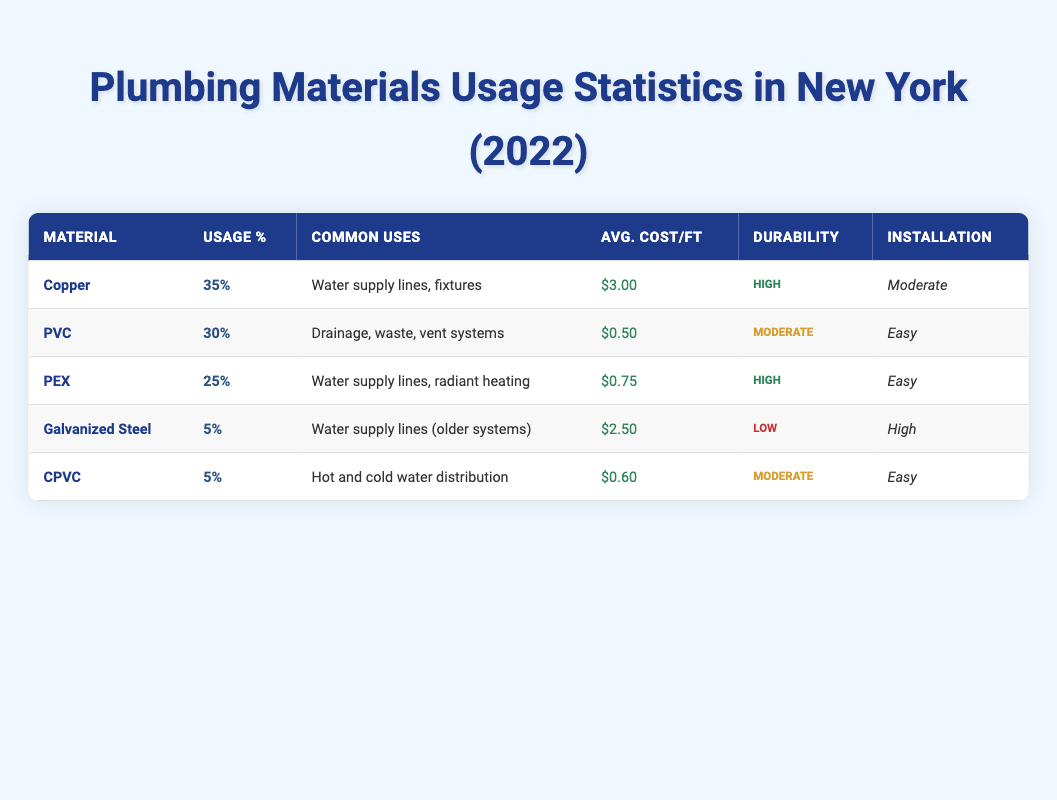What is the usage percentage of Copper among New York plumbers? The table shows that the usage percentage of Copper is listed directly under the "Usage %" column. It states 35% for Copper.
Answer: 35% Which plumbing material has the highest average cost per foot? To find the material with the highest average cost per foot, we compare the costs listed for each material: Copper ($3.00), Galvanized Steel ($2.50), PEX ($0.75), CPVC ($0.60), and PVC ($0.50). Copper has the highest cost at $3.00.
Answer: Copper Is PEX mainly used for drainage systems? The common uses for PEX are specified as "Water supply lines, radiant heating," which does not include drainage systems. Therefore, the statement is false.
Answer: No What percentage of plumbers use either PVC or CPVC? To find this percentage, we add the usage percentages of PVC (30%) and CPVC (5%). Therefore, 30% + 5% = 35%.
Answer: 35% How does the installation complexity of Copper compare to that of PVC? The table states that Copper has a moderate installation complexity, while PVC has an easy installation complexity. By comparing these two, we see that Copper is more complex to install than PVC.
Answer: Copper is more complex to install than PVC Which materials have a durability rating of "High"? By reviewing the durability ratings, we see that both Copper and PEX have a rating of "High." Thus, the answer consists of these two materials.
Answer: Copper and PEX What is the average cost per foot of the plumbing materials listed? To find the average cost per foot, we sum the costs: $3.00 (Copper) + $0.50 (PVC) + $0.75 (PEX) + $2.50 (Galvanized Steel) + $0.60 (CPVC) = $7.35. Then divide by 5 (the number of materials): $7.35 / 5 = $1.47.
Answer: $1.47 What plumbing material has the lowest durability rating? The durability ratings show that Galvanized Steel has a "Low" durability rating, which is the lowest compared to the others, which are either "Moderate" or "High."
Answer: Galvanized Steel Does PVC have a higher usage percentage than PEX? The usages are shown in the table: PVC has 30% and PEX has 25%. Since 30% is greater than 25%, the statement is true.
Answer: Yes 